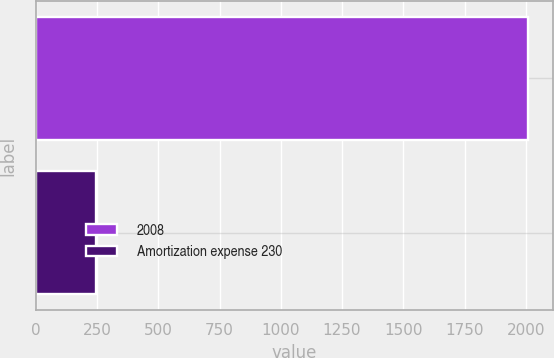Convert chart to OTSL. <chart><loc_0><loc_0><loc_500><loc_500><bar_chart><fcel>2008<fcel>Amortization expense 230<nl><fcel>2009<fcel>247<nl></chart> 